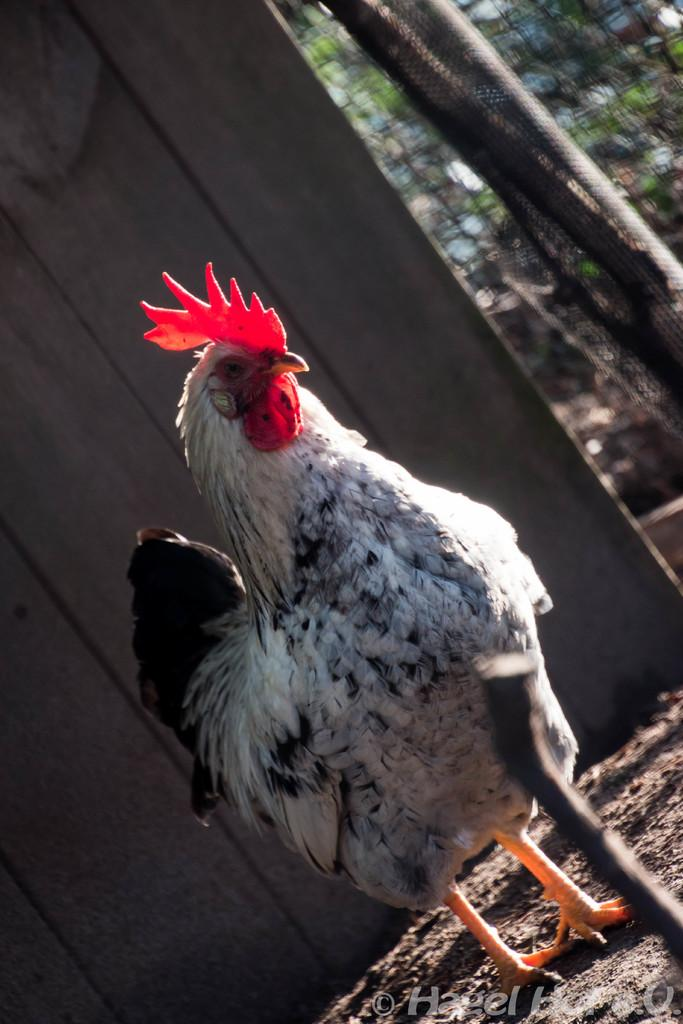What type of animal is in the image? There is a cock in the image. What can be seen in the background of the image? There is a wooden wall in the background of the image. How would you describe the background of the image? The background is blurry. What type of clock is hanging on the wall in the image? There is no clock present in the image; it features a cock and a wooden wall in the background. 